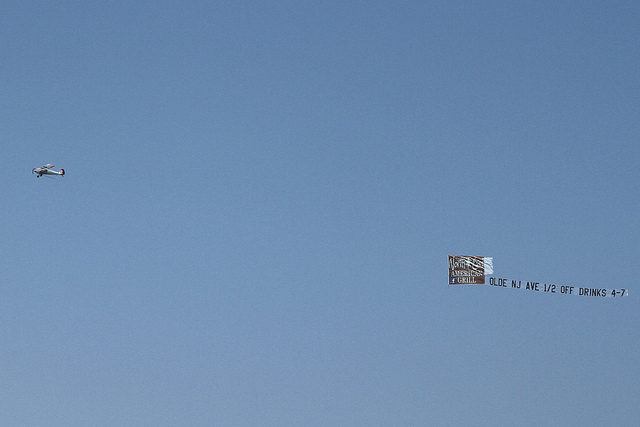Read and extract the text from this image. OLOE 1/2 OFF DRINKS 4 7 GRILL AVE NJ 